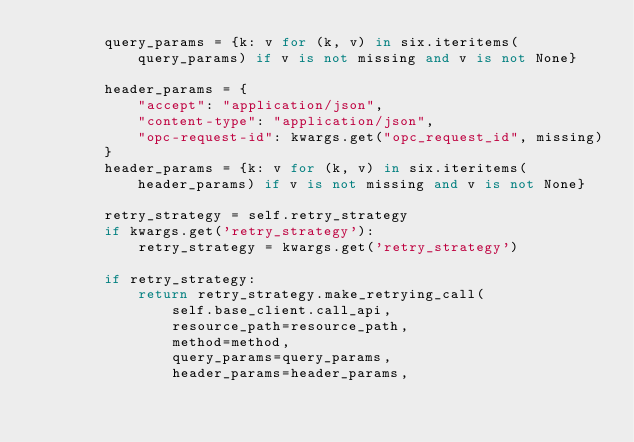Convert code to text. <code><loc_0><loc_0><loc_500><loc_500><_Python_>        query_params = {k: v for (k, v) in six.iteritems(query_params) if v is not missing and v is not None}

        header_params = {
            "accept": "application/json",
            "content-type": "application/json",
            "opc-request-id": kwargs.get("opc_request_id", missing)
        }
        header_params = {k: v for (k, v) in six.iteritems(header_params) if v is not missing and v is not None}

        retry_strategy = self.retry_strategy
        if kwargs.get('retry_strategy'):
            retry_strategy = kwargs.get('retry_strategy')

        if retry_strategy:
            return retry_strategy.make_retrying_call(
                self.base_client.call_api,
                resource_path=resource_path,
                method=method,
                query_params=query_params,
                header_params=header_params,</code> 